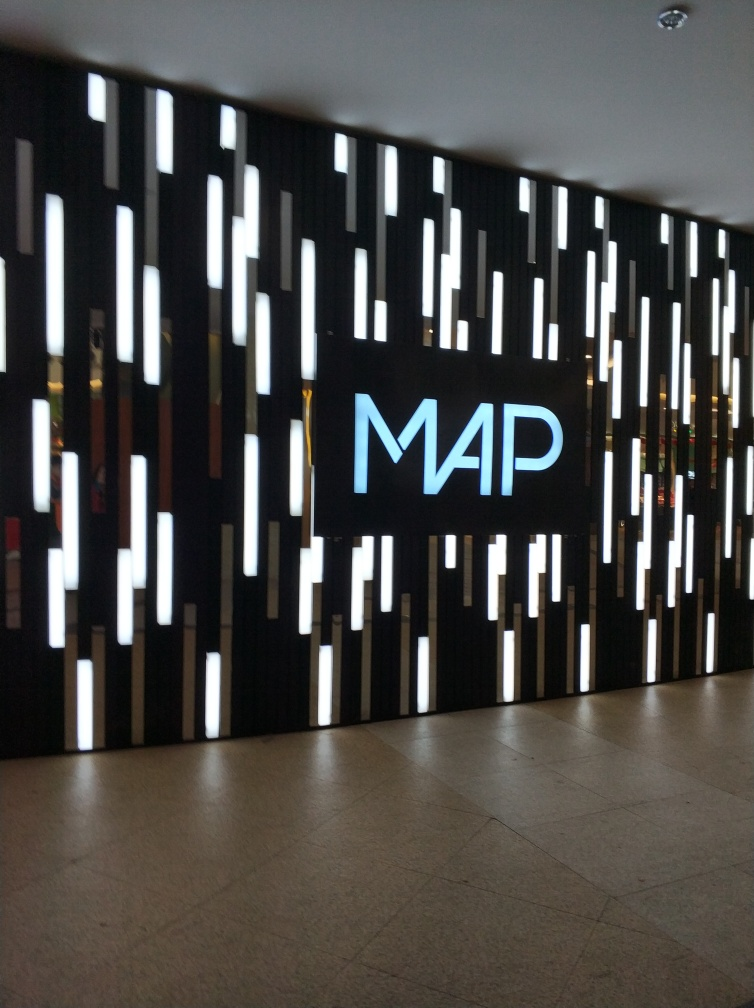Does the main subject, the wall, retain most of its texture details?
A. No
B. Yes
Answer with the option's letter from the given choices directly.
 B. 